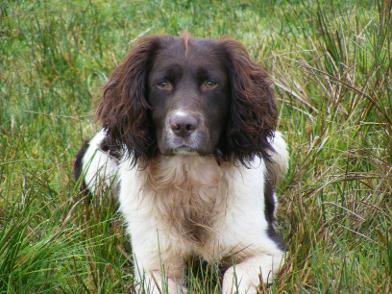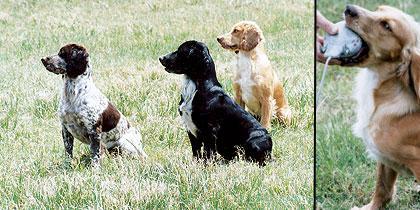The first image is the image on the left, the second image is the image on the right. Examine the images to the left and right. Is the description "The combined images include a left-facing spaniel with something large held in its mouth, and a trio of three dogs sitting together in the grass." accurate? Answer yes or no. Yes. The first image is the image on the left, the second image is the image on the right. For the images displayed, is the sentence "there are two dogs in the image pair" factually correct? Answer yes or no. No. 